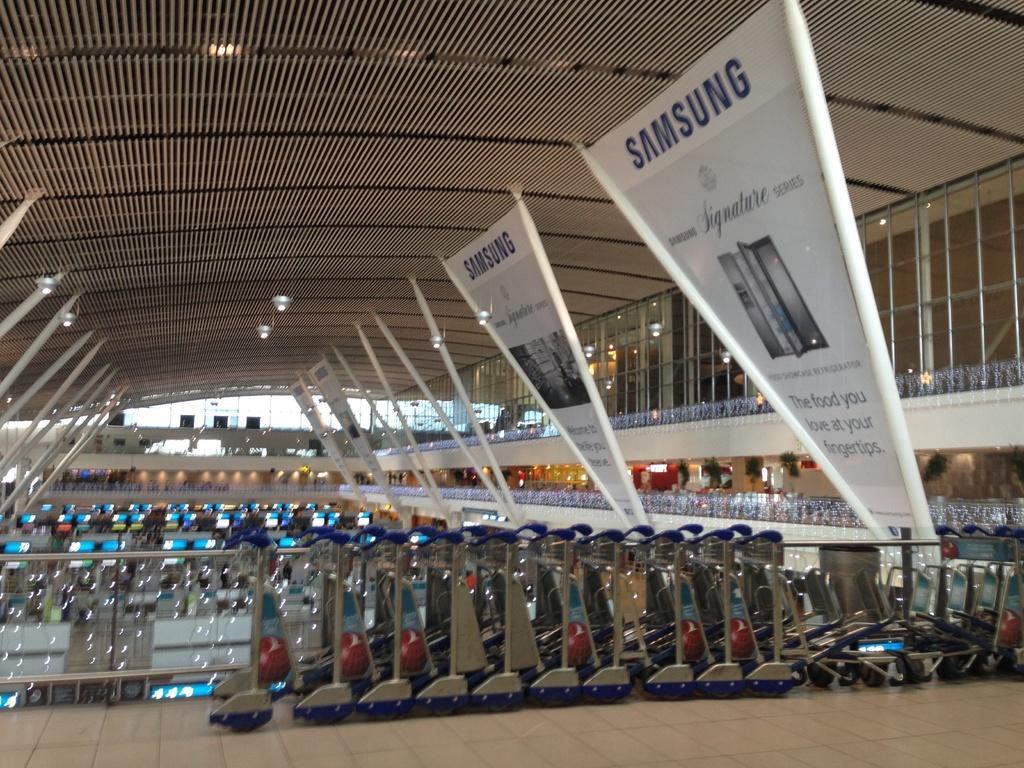In one or two sentences, can you explain what this image depicts? This image is taken inside the building. In this image there are trolleys and we can see boards. There are rods. In the background we can see lights. At the bottom there is a floor. 